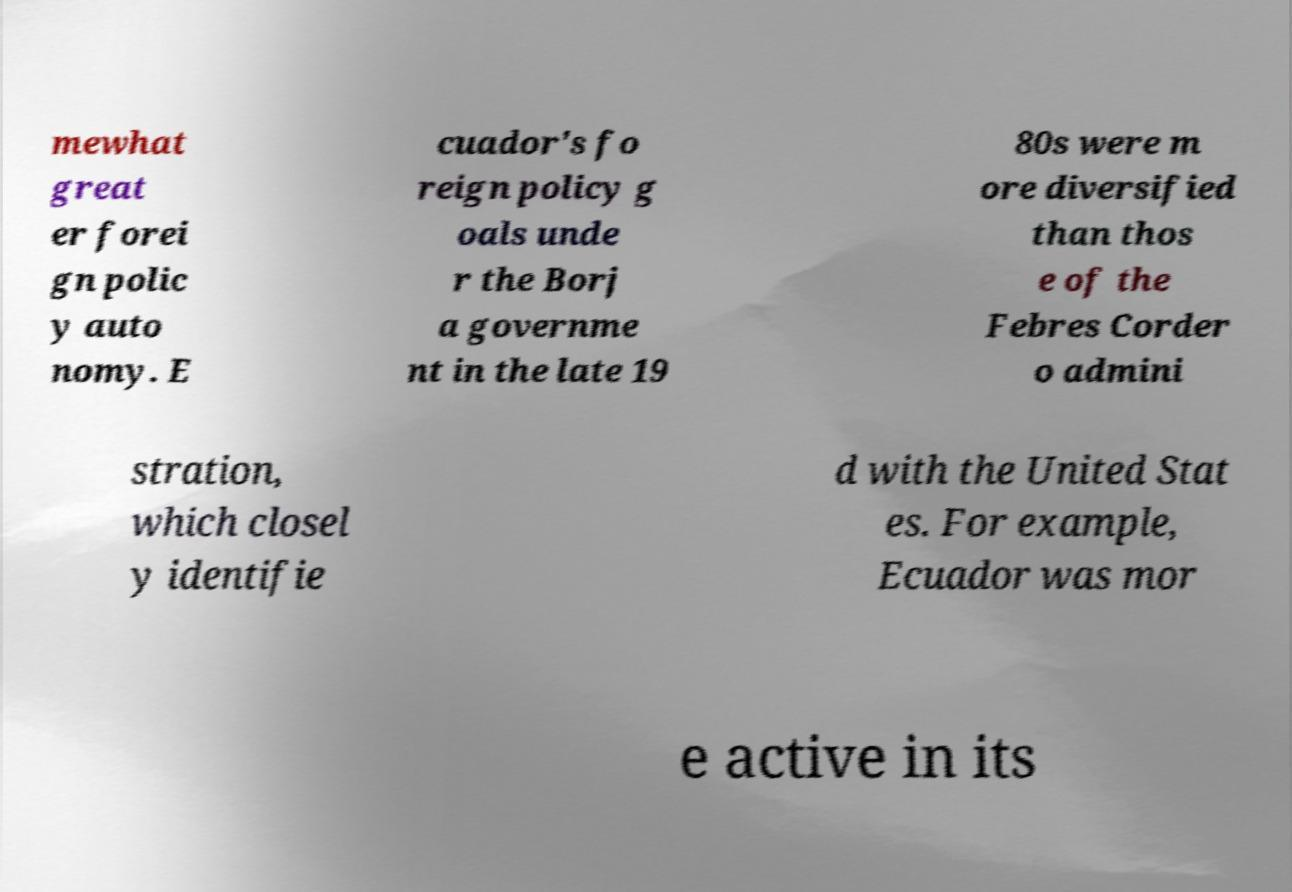There's text embedded in this image that I need extracted. Can you transcribe it verbatim? mewhat great er forei gn polic y auto nomy. E cuador's fo reign policy g oals unde r the Borj a governme nt in the late 19 80s were m ore diversified than thos e of the Febres Corder o admini stration, which closel y identifie d with the United Stat es. For example, Ecuador was mor e active in its 